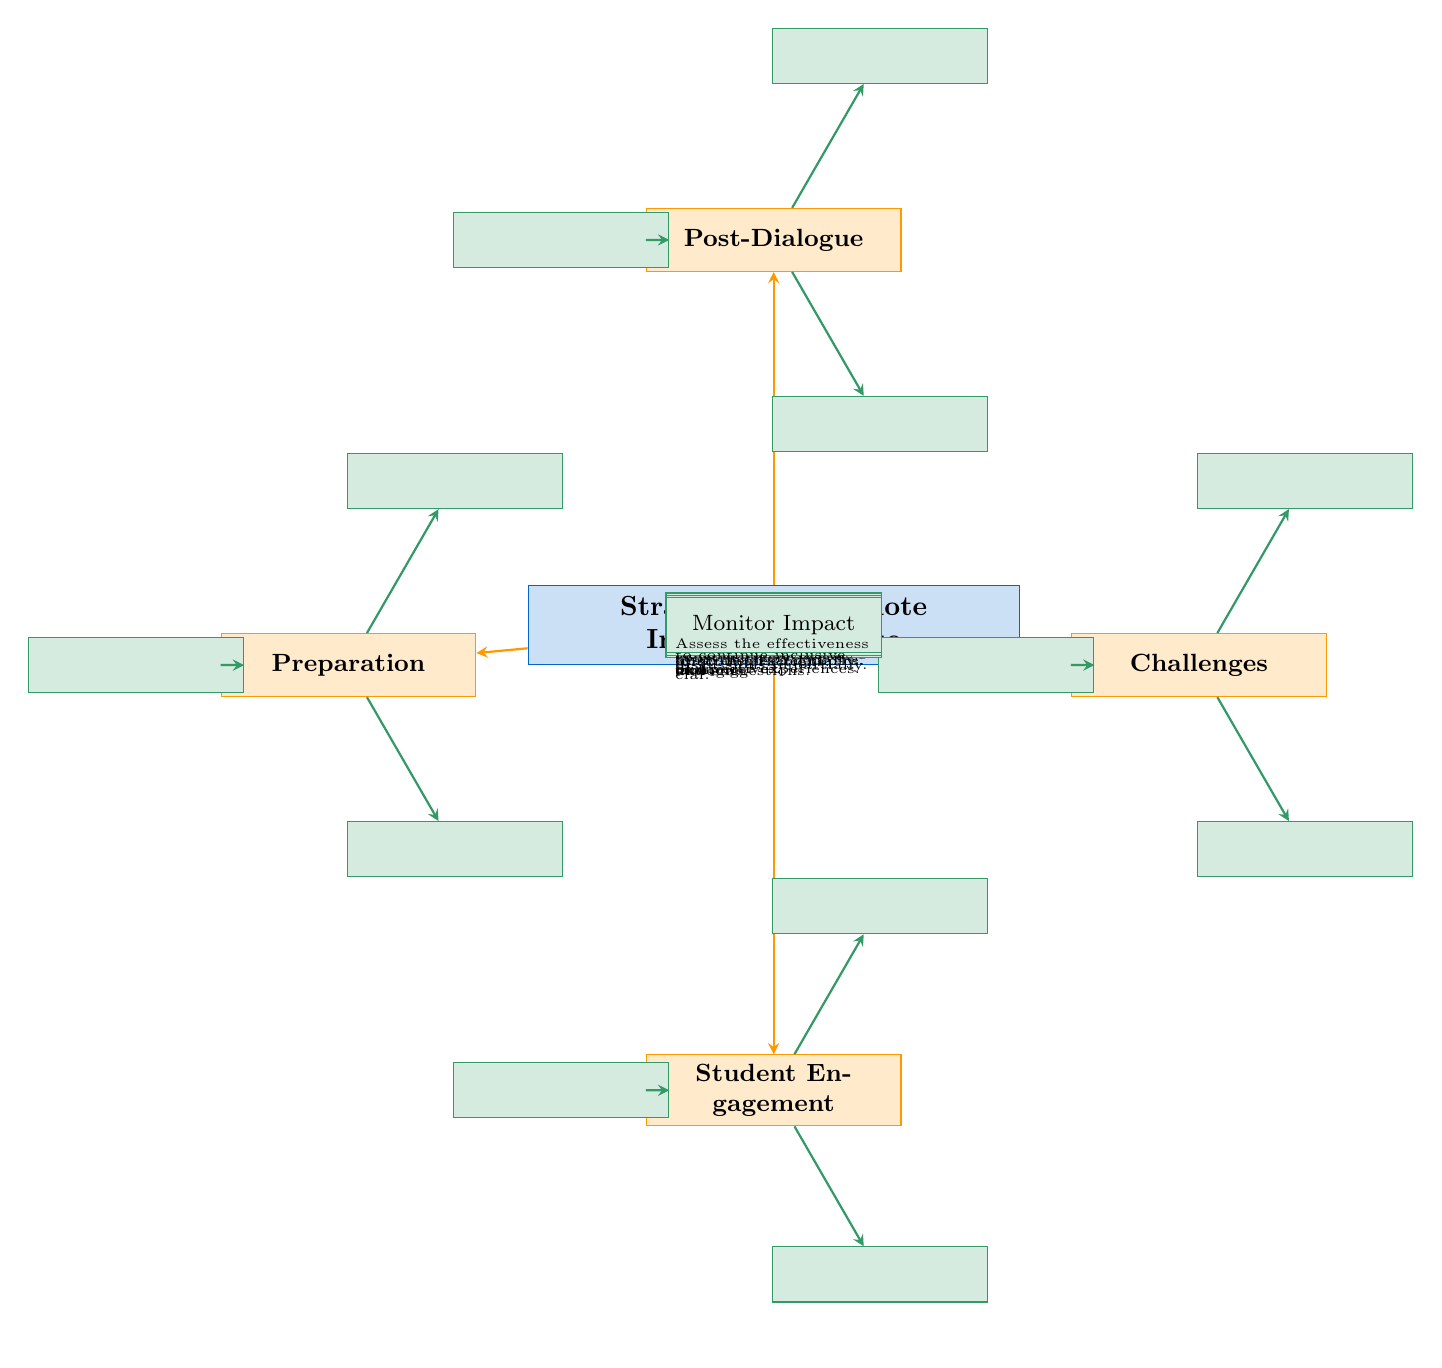What is the main focus of the diagram? The diagram's main focus is highlighted in the central node labeled "Strategies to Promote Inclusive Dialogue," which indicates the overall subject matter addressed in the diagram.
Answer: Strategies to Promote Inclusive Dialogue How many main categories are represented in the diagram? The diagram is structured into four main categories that branch out from the central node: Preparation, Student Engagement, Challenges, and Post-Dialogue. Counting these categories gives the total number.
Answer: 4 What is one technique listed under the Preparation category? To find a specific technique under Preparation, look at the nodes directly connected to this category. One of the nodes is labeled "Diverse Resources."
Answer: Diverse Resources What challenge is associated with handling disagreements? Under the Challenges category, the node labeled "Conflict Management" specifically addresses the complexity of handling disagreements constructively during discussions.
Answer: Conflict Management Which node discusses the importance of listening? The "Active Listening" node is explicitly included under the Student Engagement category, indicating the significance of listening in discussions.
Answer: Active Listening What are the follow-up activities mentioned in the diagram? In the Post-Dialogue category, the follow-up activities are represented by the node labeled "Follow-Up Activities," emphasizing the need for ongoing engagement after discussions.
Answer: Follow-Up Activities How many techniques are suggested under Student Engagement? By counting the nodes that branch out from the Student Engagement category, we find there are three listed techniques: Active Listening, Empathy Building, and Feedback Mechanisms.
Answer: 3 What potential policy restriction is highlighted in the diagram? The diagram includes a specific potential challenge regarding "Policy Restrictions," indicating that existing school policies might limit discussion topics, which is essential for understanding the context of inclusive dialogue.
Answer: Policy Restrictions What is the significance of facilitator training in the diagram? The "Facilitator Training" node under Preparation emphasizes the need for training staff to manage discussions impartially, which is crucial for fostering an inclusive environment.
Answer: Train staff to manage discussions impartially 